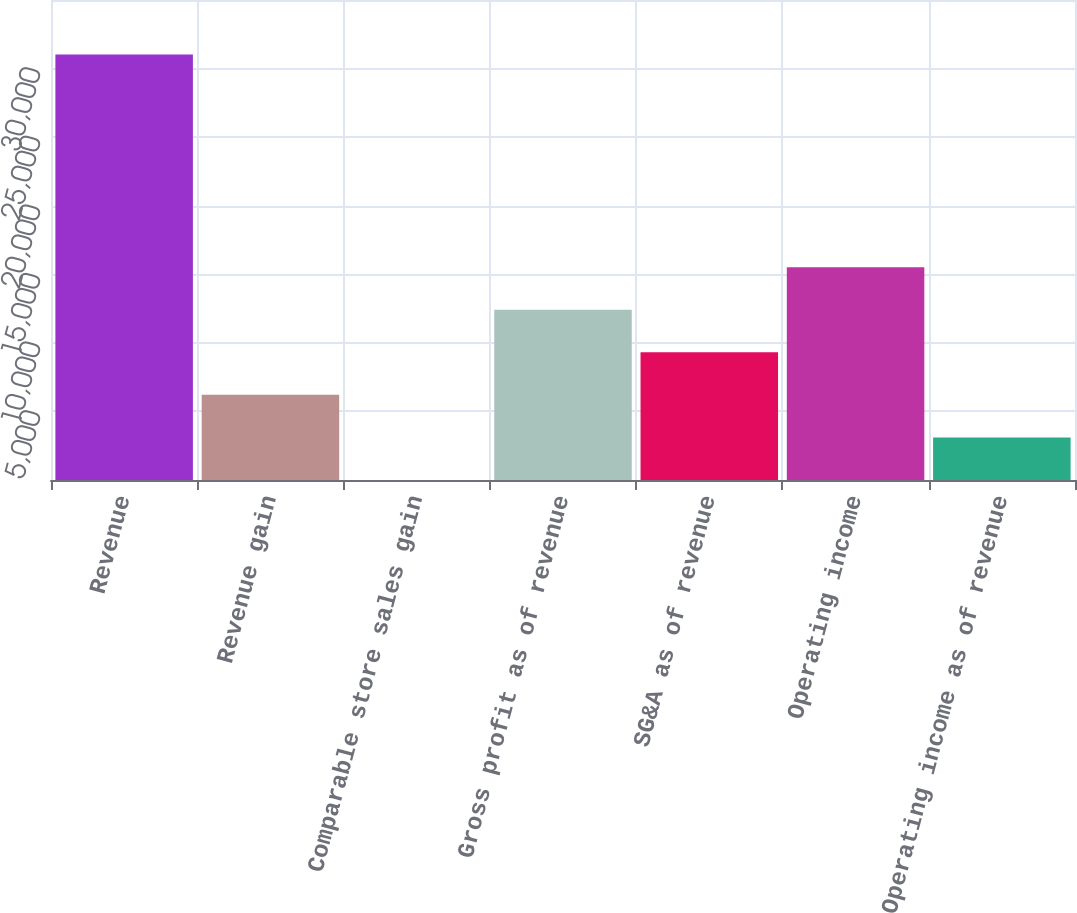Convert chart to OTSL. <chart><loc_0><loc_0><loc_500><loc_500><bar_chart><fcel>Revenue<fcel>Revenue gain<fcel>Comparable store sales gain<fcel>Gross profit as of revenue<fcel>SG&A as of revenue<fcel>Operating income<fcel>Operating income as of revenue<nl><fcel>31031<fcel>6209.48<fcel>4.1<fcel>12414.9<fcel>9312.17<fcel>15517.5<fcel>3106.79<nl></chart> 